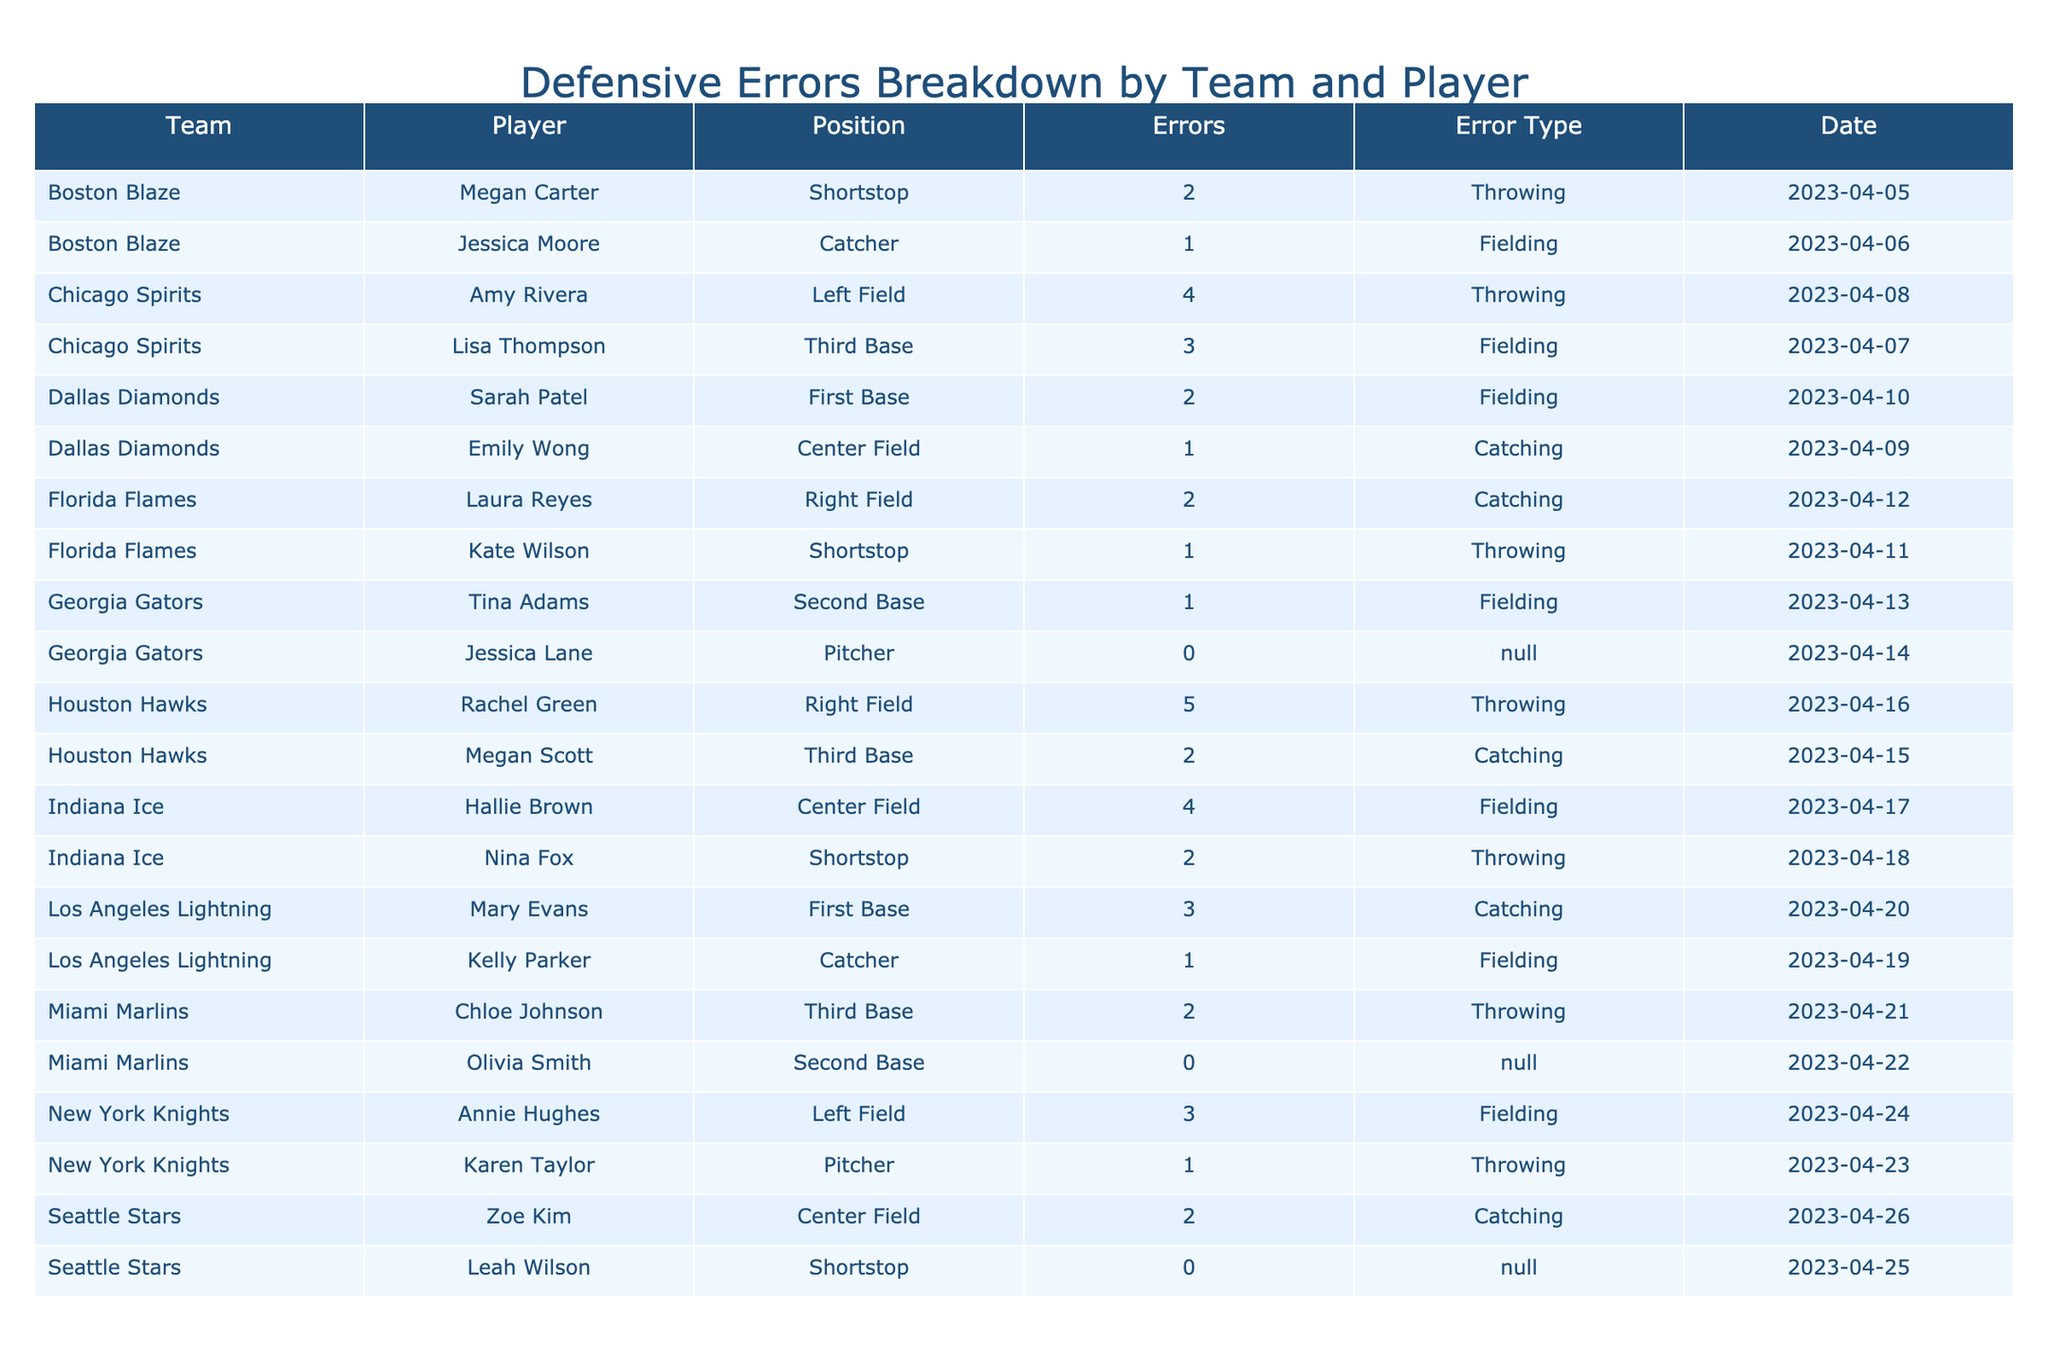What team has the most errors in the current season? By reviewing the table, we can see that Chicago Spirits has the highest number of total errors, which is 7 (3 from Lisa Thompson and 4 from Amy Rivera).
Answer: Chicago Spirits Which player has the most errors in the current season? In the table, we observe that Rachel Green from Houston Hawks has 5 errors, which is the highest for an individual player.
Answer: Rachel Green How many errors did Boston Blaze make in total? To find the total errors for Boston Blaze, we add Megan Carter's errors (2) and Jessica Moore's errors (1), yielding a total of 3 errors.
Answer: 3 Did any player have zero errors in the current season? Reviewing the table, we see that Jessica Lane from Georgia Gators and Olivia Smith from Miami Marlins both have zero errors recorded in the season. Therefore, the answer is true.
Answer: Yes What is the average number of errors made by players in the position of Catcher? There are three catchers: Jessica Moore (1), Emily Wong (1), and Kelly Parker (1). The sum is 3 errors, and the average would be 3 errors divided by 3 players, equalling 1.
Answer: 1 Which team had the highest number of throwing errors? To determine the highest number of throwing errors, we filter the table for throwing errors. Houston Hawks (5), Chicago Spirits (4), and Boston Blaze (2) appear, making Houston Hawks the team with the highest number of throwing errors.
Answer: Houston Hawks Is there any player who solely committed fielding errors? Examining the table, we find Lisa Thompson and Sarah Patel, both of whom had fielding errors. However, there are also players who committed errors in other categories as well. Thus, there is no player limited to fielding errors alone.
Answer: No Which team had the fewest total errors? Analyzing the teams, we find that both Georgia Gators and Miami Marlins have a total of 1 error each, which is the least among all teams.
Answer: Georgia Gators and Miami Marlins How many more throwing errors were committed by Houston Hawks compared to Boston Blaze? Houston Hawks had 5 throwing errors while Boston Blaze had 2. The difference between these two is 5 minus 2, which equals 3.
Answer: 3 